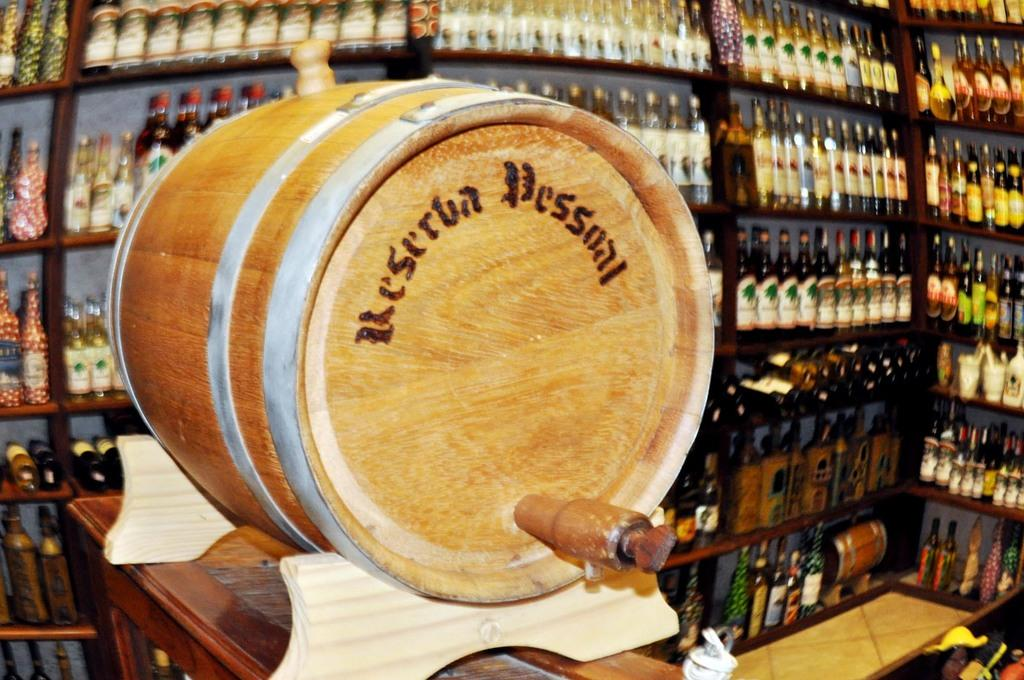What can be seen in the background of the image? There are bottles arranged in a rack in the background of the image. What is present on the table in the image? There is a showpiece on the table. What material is the showpiece made of? The showpiece is made of wood. Is there steam coming out of the showpiece in the image? No, there is no steam coming out of the showpiece in the image. Can you see a hill in the background of the image? No, there is no hill visible in the image. 